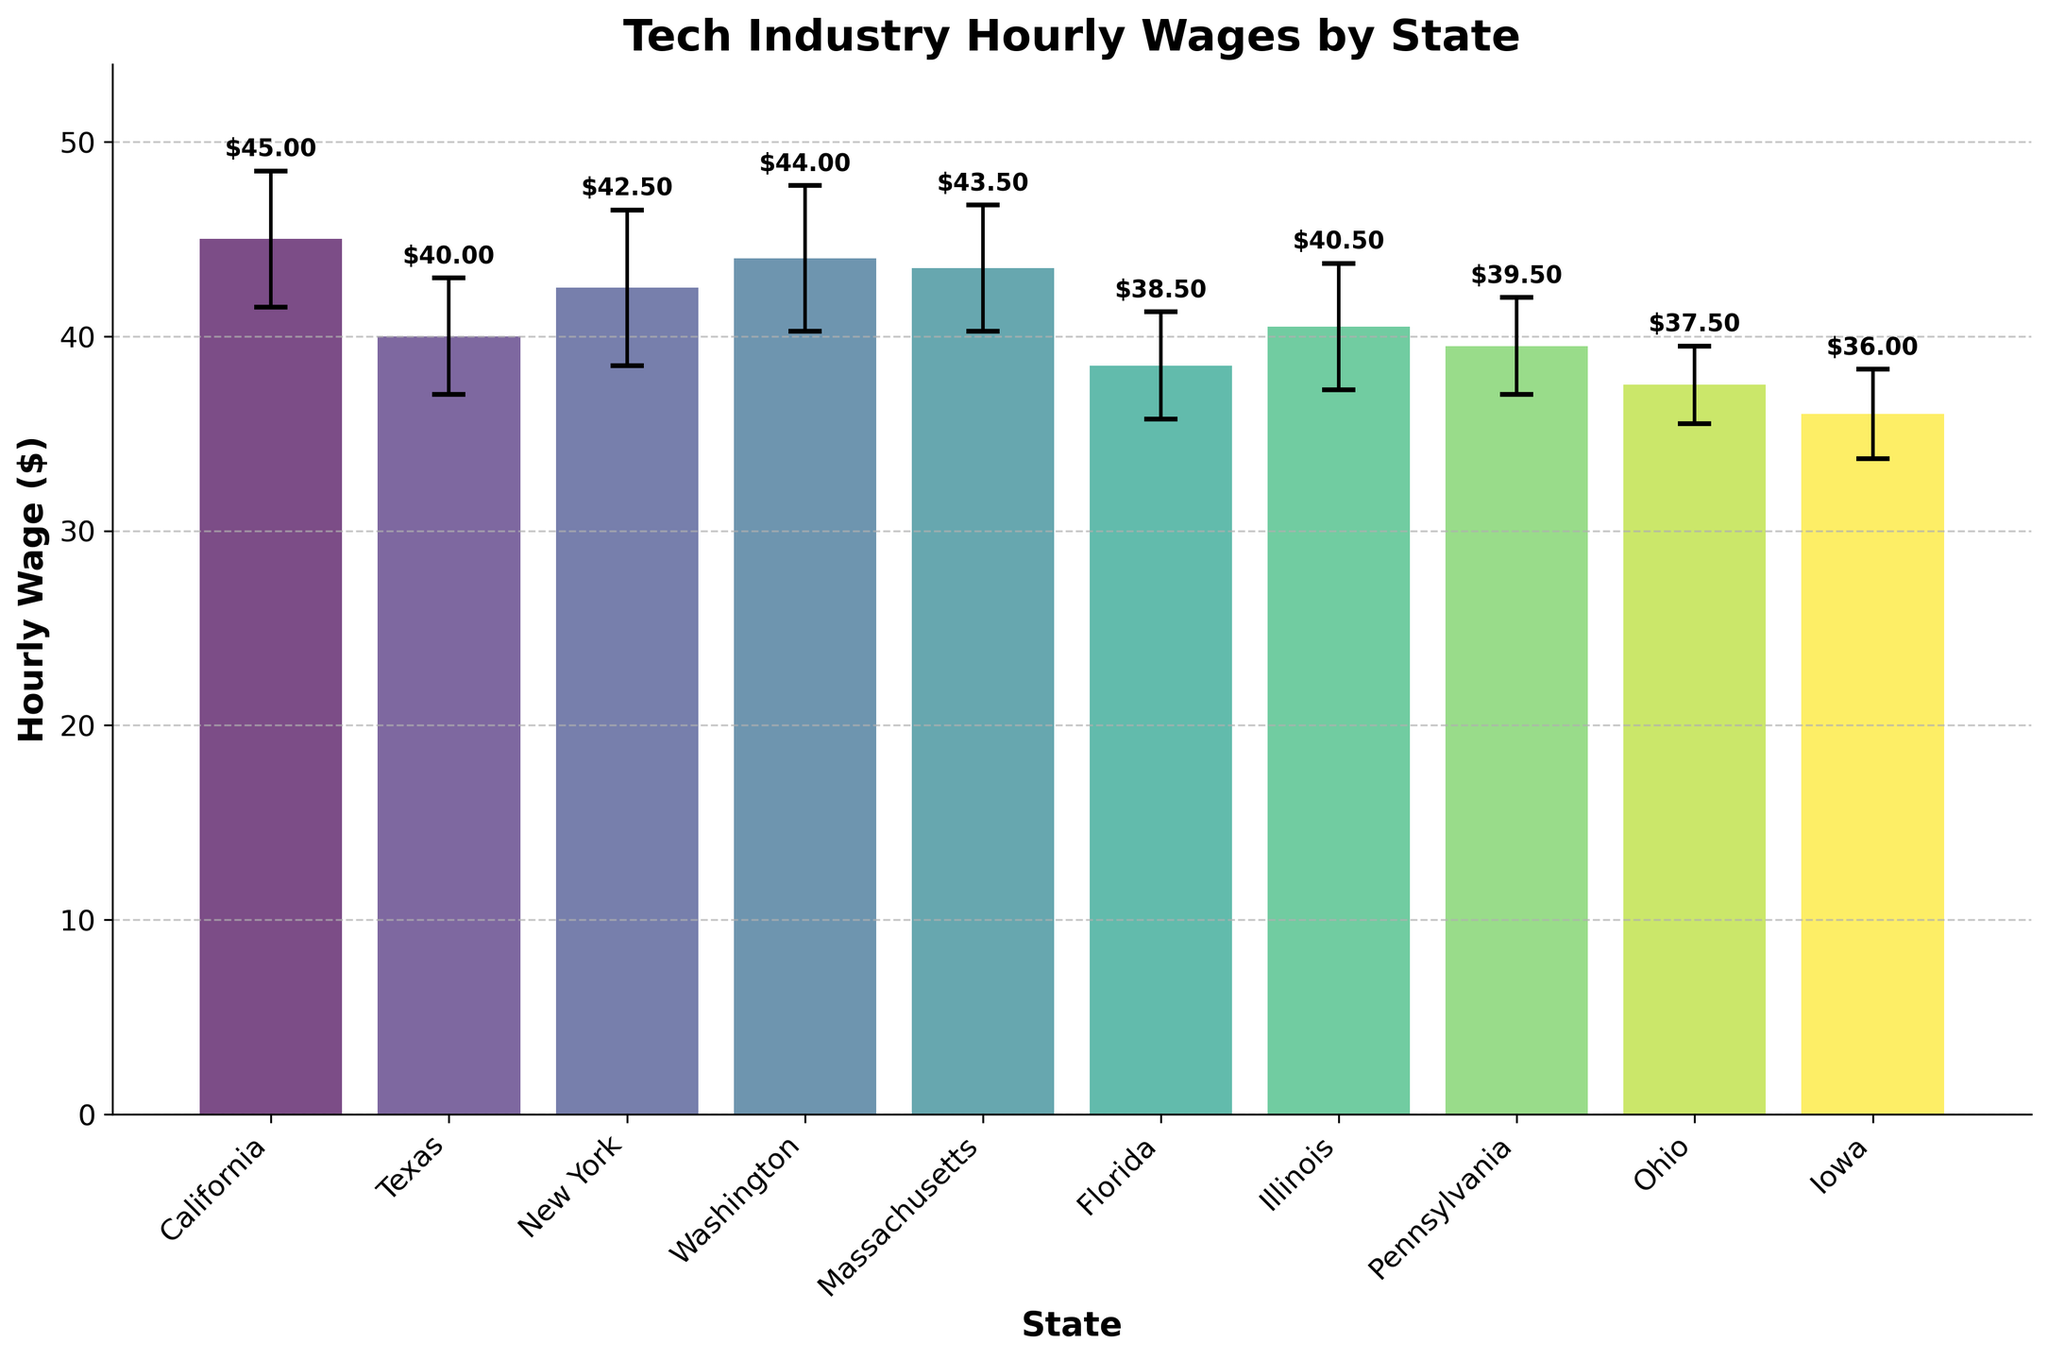How many states are compared in the figure? Count the number of bars on the x-axis, each representing a state.
Answer: 10 What's the hourly wage in Massachusetts? Look at the height of the bar labeled "Massachusetts" on the x-axis and read the corresponding value.
Answer: $43.50 Which state has the highest mean hourly wage? Identify the tallest bar on the y-axis and read the corresponding state label.
Answer: California How much higher is California's mean hourly wage compared to Iowa's? Subtract Iowa's mean wage from California's mean wage ($45.00 - $36.00).
Answer: $9.00 What's the average hourly wage across all states shown? Add up all the mean wages and then divide by the number of states: (45.00 + 40.00 + 42.50 + 44.00 + 43.50 + 38.50 + 40.50 + 39.50 + 37.50 + 36.00) / 10 = 407.00 / 10
Answer: $40.70 Which states have mean wages above $40? Identify states with bars that reach above the $40 mark on the y-axis: California, Texas, New York, Washington, Massachusetts, and Illinois.
Answer: California, Texas, New York, Washington, Massachusetts, Illinois What's the difference between the highest and lowest mean hourly wages? Subtract the lowest mean hourly wage from the highest mean hourly wage: ($45.00 - $36.00).
Answer: $9.00 Which state has the largest variability in hourly wage? Look for the state with the highest error bar (the vertical line extending from the top of the bar): New York, with the error bar of ±4.00.
Answer: New York What's the sum of the standard errors for all states? Add up all the standard errors: 3.50 + 3.00 + 4.00 + 3.75 + 3.25 + 2.75 + 3.25 + 2.50 + 2.00 + 2.30.
Answer: 30.30 Are there any states with the same mean hourly wage? Check if any bars align horizontally at the same height: None of the bars share the exact same height.
Answer: No 